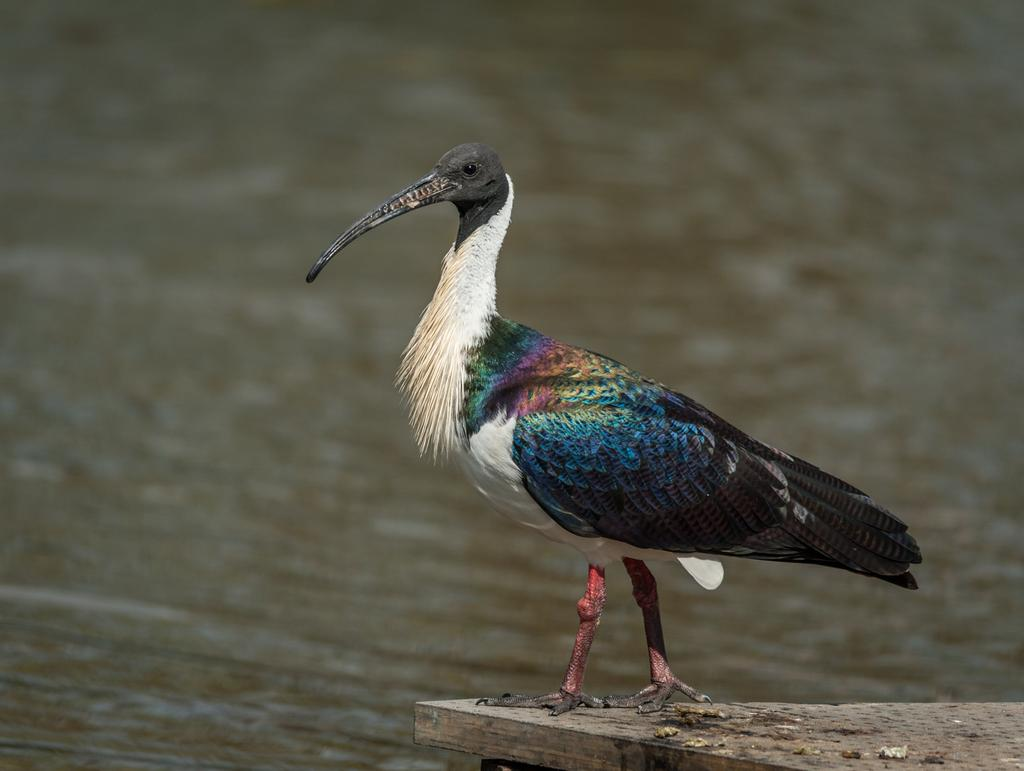What type of animal can be seen in the image? There is a bird in the image. What is the bird standing on? The bird is standing on a wooden surface. Can you describe the environment in the image? There is water visible in the image. What type of fruit is the bird holding in the image? There is no fruit present in the image, and the bird is not holding anything. 